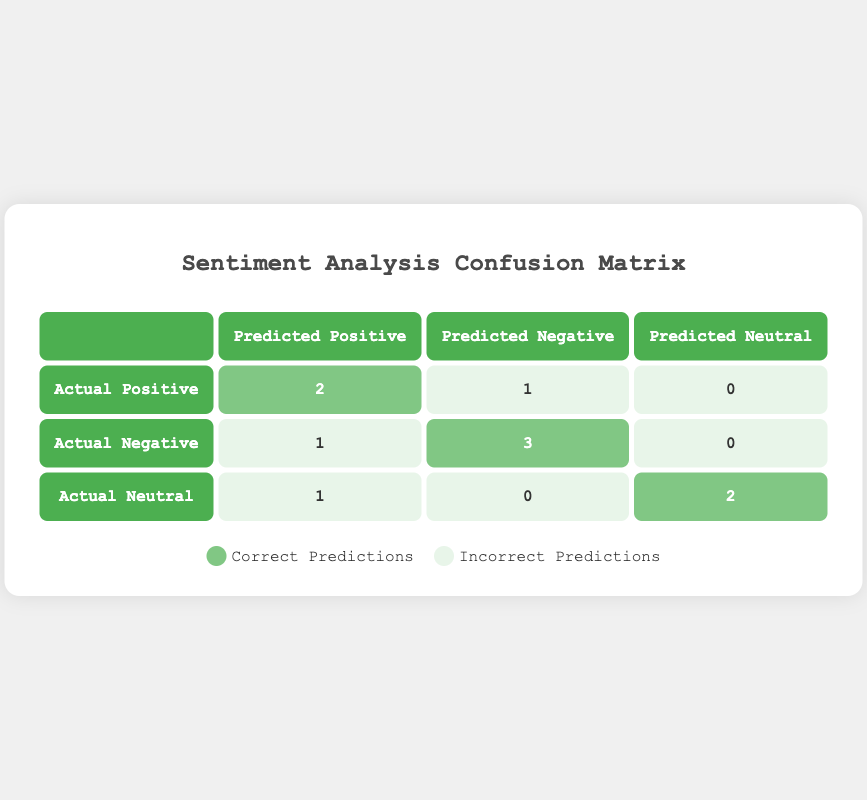What is the total count of correct predictions in the confusion matrix? To find the correct predictions, we look at the diagonal elements of the confusion matrix. The correct predictions are: 2 (Positive) + 3 (Negative) + 2 (Neutral) = 7.
Answer: 7 How many actual reviews were predicted as Positive? By analyzing the row for Actual Positive, we see that there were 2 predictions classified as Positive (correct) and 1 classification as Negative, and 0 as Neutral. Thus, the total is 2 + 1 + 0 = 3.
Answer: 3 What is the percentage of Neutral reviews that were predicted correctly? The total of Actual Neutral reviews is 3 (1 correct and 2 incorrect). To find the percentage, we take the number of correct predictions, which is 2, divide by the total number (3), and then multiply by 100: (2 / 3) * 100 = approximately 66.67%.
Answer: Approximately 66.67% Is there any Actual Positive review that was predicted as Neutral? Checking the Actual Positive row, we see that there are 0 cases where an Actual Positive review was predicted as Neutral.
Answer: No What is the difference in the number of correct predictions between Positive and Negative categories? The number of correct Positive predictions is 2 and the number of correct Negative predictions is 3. The difference is calculated as 3 - 2 = 1.
Answer: 1 What proportion of reviews in the Negative category were incorrectly classified? In the Negative category (Actual Negative), there are 3 correct predictions and 1 incorrect (predicted as Positive). To find the proportion of incorrect predictions, we calculate 1 (incorrect) out of 4 total Negative reviews, resulting in 1 / 4 = 0.25 or 25%.
Answer: 25% How many reviews were predicted to be Neutral? Looking across the whole confusion matrix, we see there are 0 predicted Neutral in the Actual Positive row, 0 in the Actual Negative row, and 2 in the Actual Neutral row. Adding these gives 2 + 0 + 0 = 2.
Answer: 2 What type of error occurs when actual Positive reviews are predicted as Negative? Based on the table, there is 1 instance where an Actual Positive review was predicted as Negative. This is considered a false negative, meaning we incorrectly labeled a Positive review as Negative.
Answer: False negative 